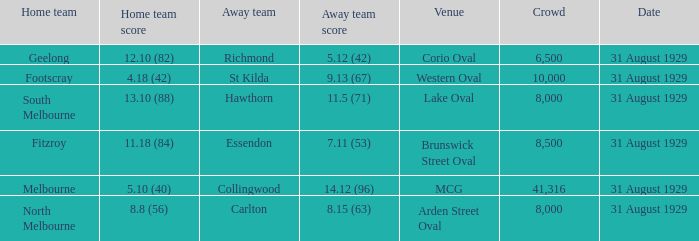Could you help me parse every detail presented in this table? {'header': ['Home team', 'Home team score', 'Away team', 'Away team score', 'Venue', 'Crowd', 'Date'], 'rows': [['Geelong', '12.10 (82)', 'Richmond', '5.12 (42)', 'Corio Oval', '6,500', '31 August 1929'], ['Footscray', '4.18 (42)', 'St Kilda', '9.13 (67)', 'Western Oval', '10,000', '31 August 1929'], ['South Melbourne', '13.10 (88)', 'Hawthorn', '11.5 (71)', 'Lake Oval', '8,000', '31 August 1929'], ['Fitzroy', '11.18 (84)', 'Essendon', '7.11 (53)', 'Brunswick Street Oval', '8,500', '31 August 1929'], ['Melbourne', '5.10 (40)', 'Collingwood', '14.12 (96)', 'MCG', '41,316', '31 August 1929'], ['North Melbourne', '8.8 (56)', 'Carlton', '8.15 (63)', 'Arden Street Oval', '8,000', '31 August 1929']]} What was the away team when the game was at corio oval? Richmond. 